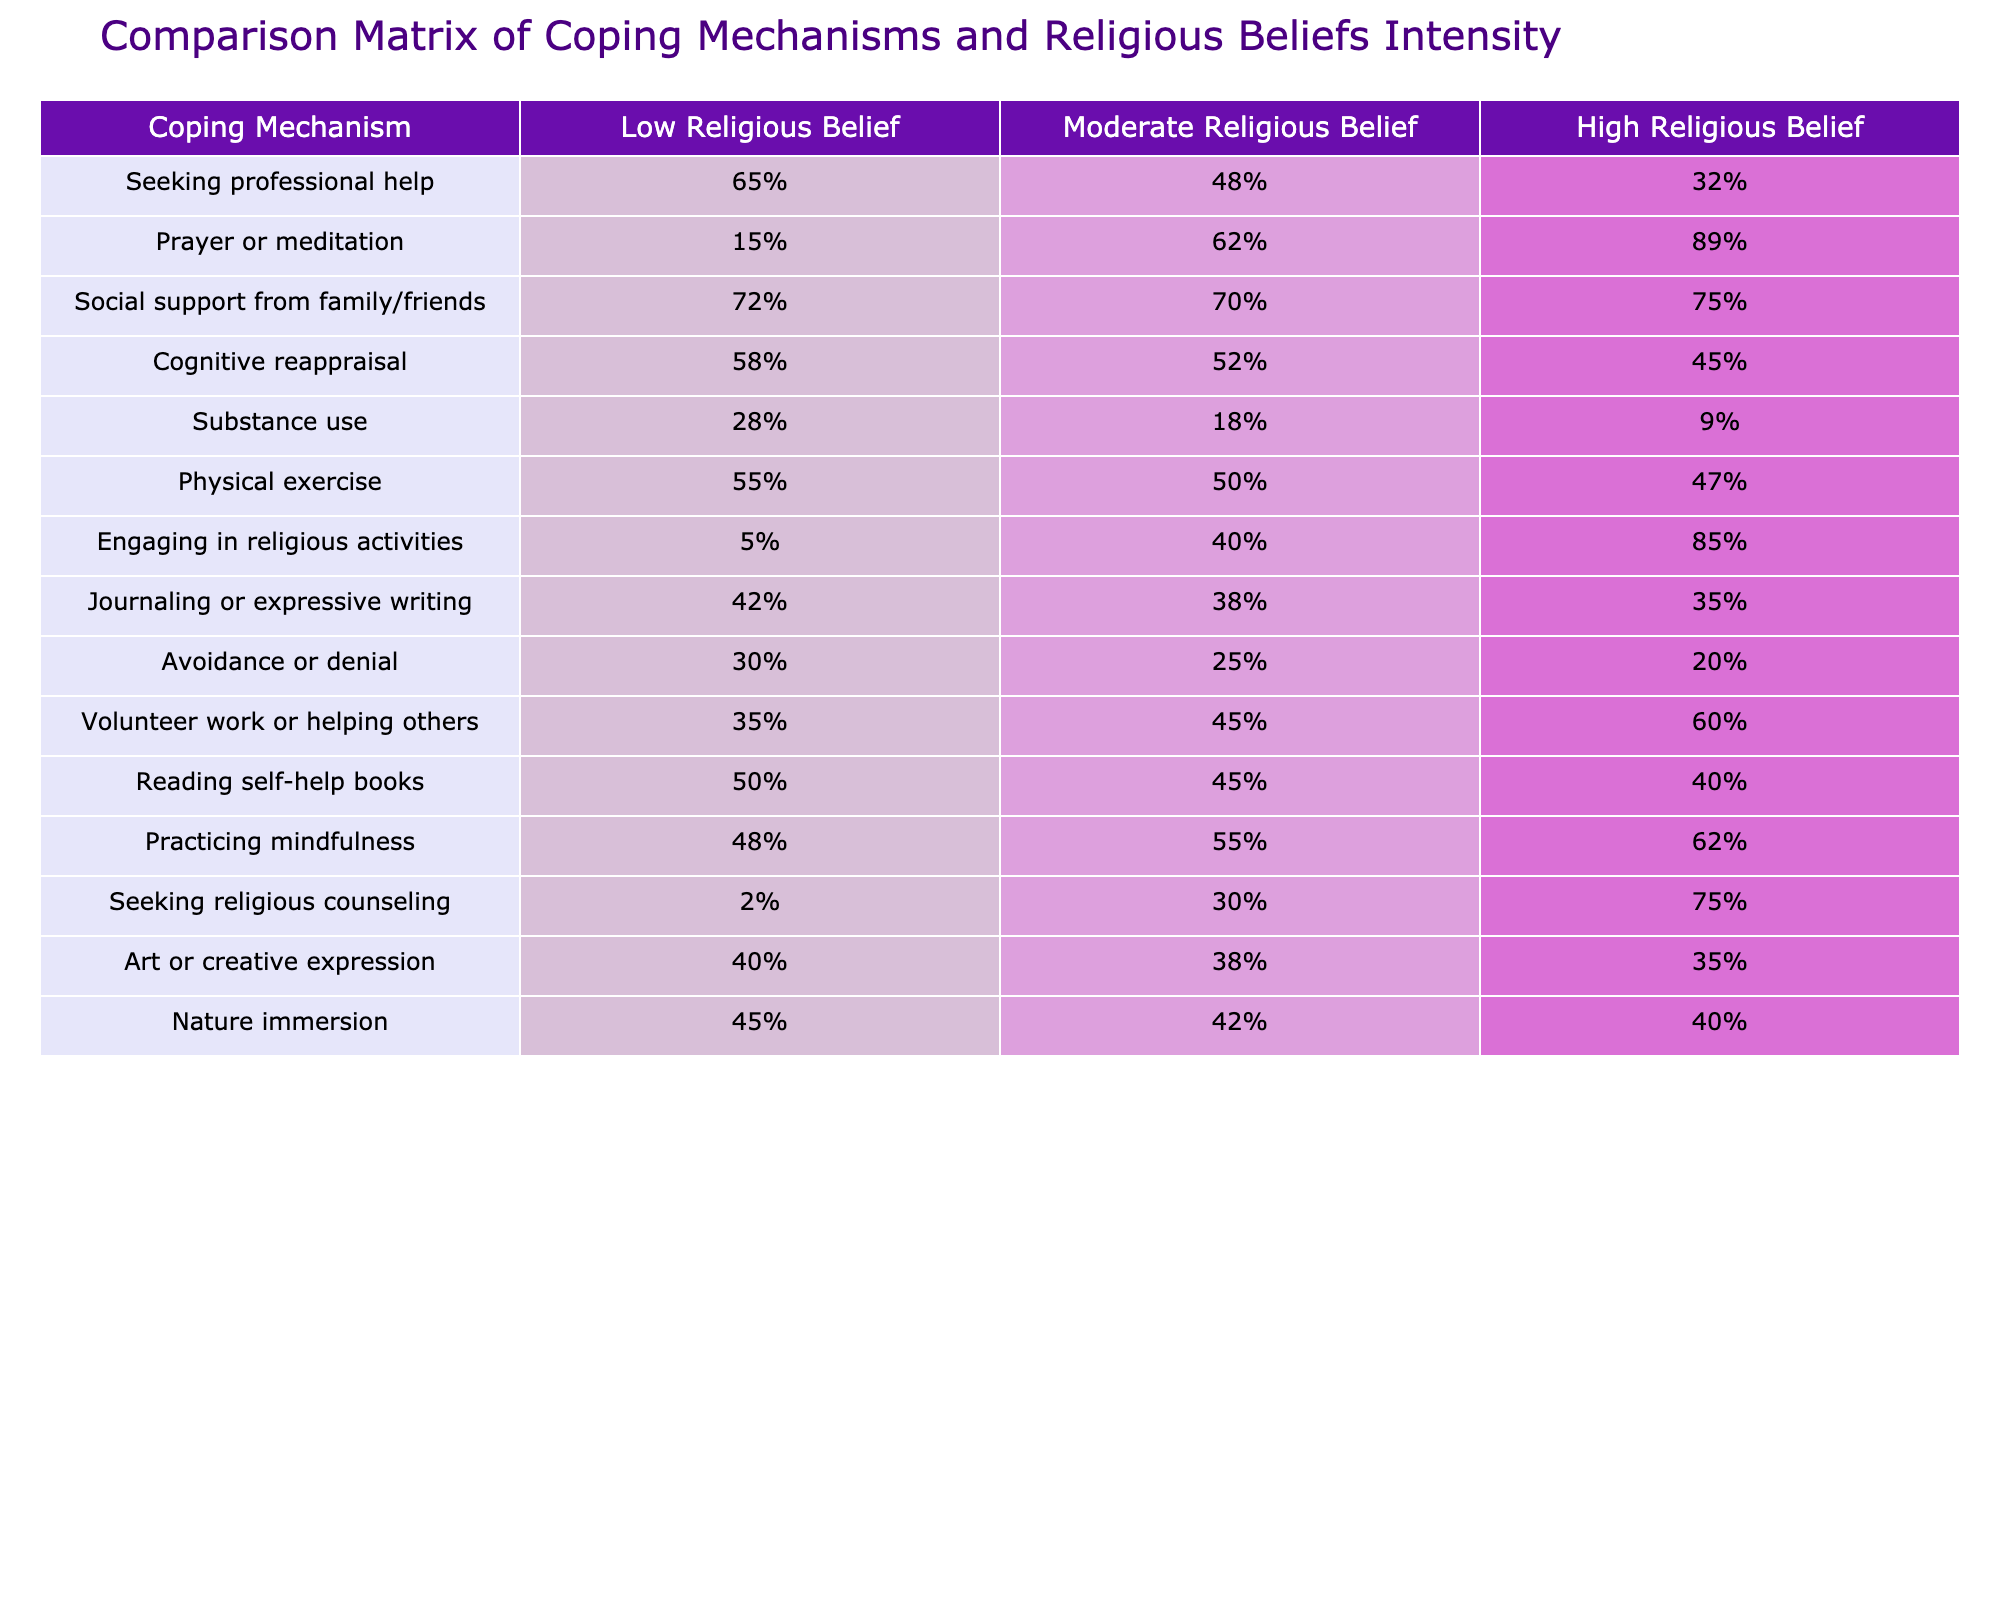What coping mechanism has the highest percentage among those with low religious beliefs? The table shows the percentage of each coping mechanism for low religious belief individuals. The highest percentage is 72% for social support from family/friends.
Answer: Social support from family/friends What is the percentage of individuals with high religious beliefs who engage in prayer or meditation? The table indicates that 89% of individuals with high religious beliefs engage in prayer or meditation.
Answer: 89% What is the difference in the percentage of seeking professional help between low and high religious belief groups? For low religious belief, the percentage is 65%, and for high religious belief, it is 32%. The difference is 65% - 32% = 33%.
Answer: 33% Does engaging in religious activities have a higher percentage for moderate or high religious beliefs? The table shows 40% for moderate religious beliefs and 85% for high religious beliefs. Since 85% is greater than 40%, engaging in religious activities has a higher percentage for high religious beliefs.
Answer: Yes What is the average percentage of social support from family/friends across all three belief intensity groups? The percentages for social support are 72%, 70%, and 75%. To find the average, sum these values: 72 + 70 + 75 = 217, and then divide by 3. The average is 217/3 = approximately 72.33%.
Answer: 72.33% Which coping mechanism shows the least engagement among those with low religious beliefs? In the low religious belief group, the coping mechanism with the least engagement is seeking religious counseling, with only 2%.
Answer: 2% What percentage of individuals with moderate religious beliefs use substance use as a coping mechanism compared to those with low religious beliefs? The percentage for moderate religious beliefs is 18%, and for low religious beliefs, it is 28%. Therefore, individuals with low religious beliefs use substance use more compared to those with moderate beliefs (28% > 18%).
Answer: Yes What is the most popular coping mechanism for individuals with moderate religious beliefs? Looking at the moderate religious belief percentages, prayer or meditation has the highest percentage at 62%.
Answer: Prayer or meditation What is the total percentage of those using prayer or meditation and engaging in religious activities for individuals with high religious beliefs? The percentage for prayer or meditation is 89%, and for engaging in religious activities, it is 85%. Summing these gives 89% + 85% = 174%.
Answer: 174% For individuals with low religious beliefs, which two coping mechanisms have percentages above 50%? The coping mechanisms with percentages above 50% for low religious beliefs are social support from family/friends (72%) and physical exercise (55%).
Answer: Social support from family/friends and physical exercise 